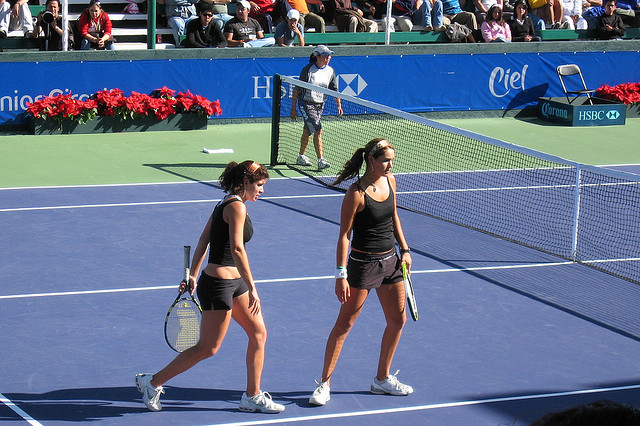They won or lose the game? It is difficult to determine from the image alone whether the players won or lost the game, as there are no clear indicators of victory or defeat such as expressions of joy or disappointment. Additionally, analyzing body language and expressions without context can be misleading. A closer look at the scoreboards, spectators' reactions, or additional moments from the game would be necessary to accurately answer this question. 